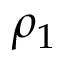<formula> <loc_0><loc_0><loc_500><loc_500>\rho _ { 1 }</formula> 